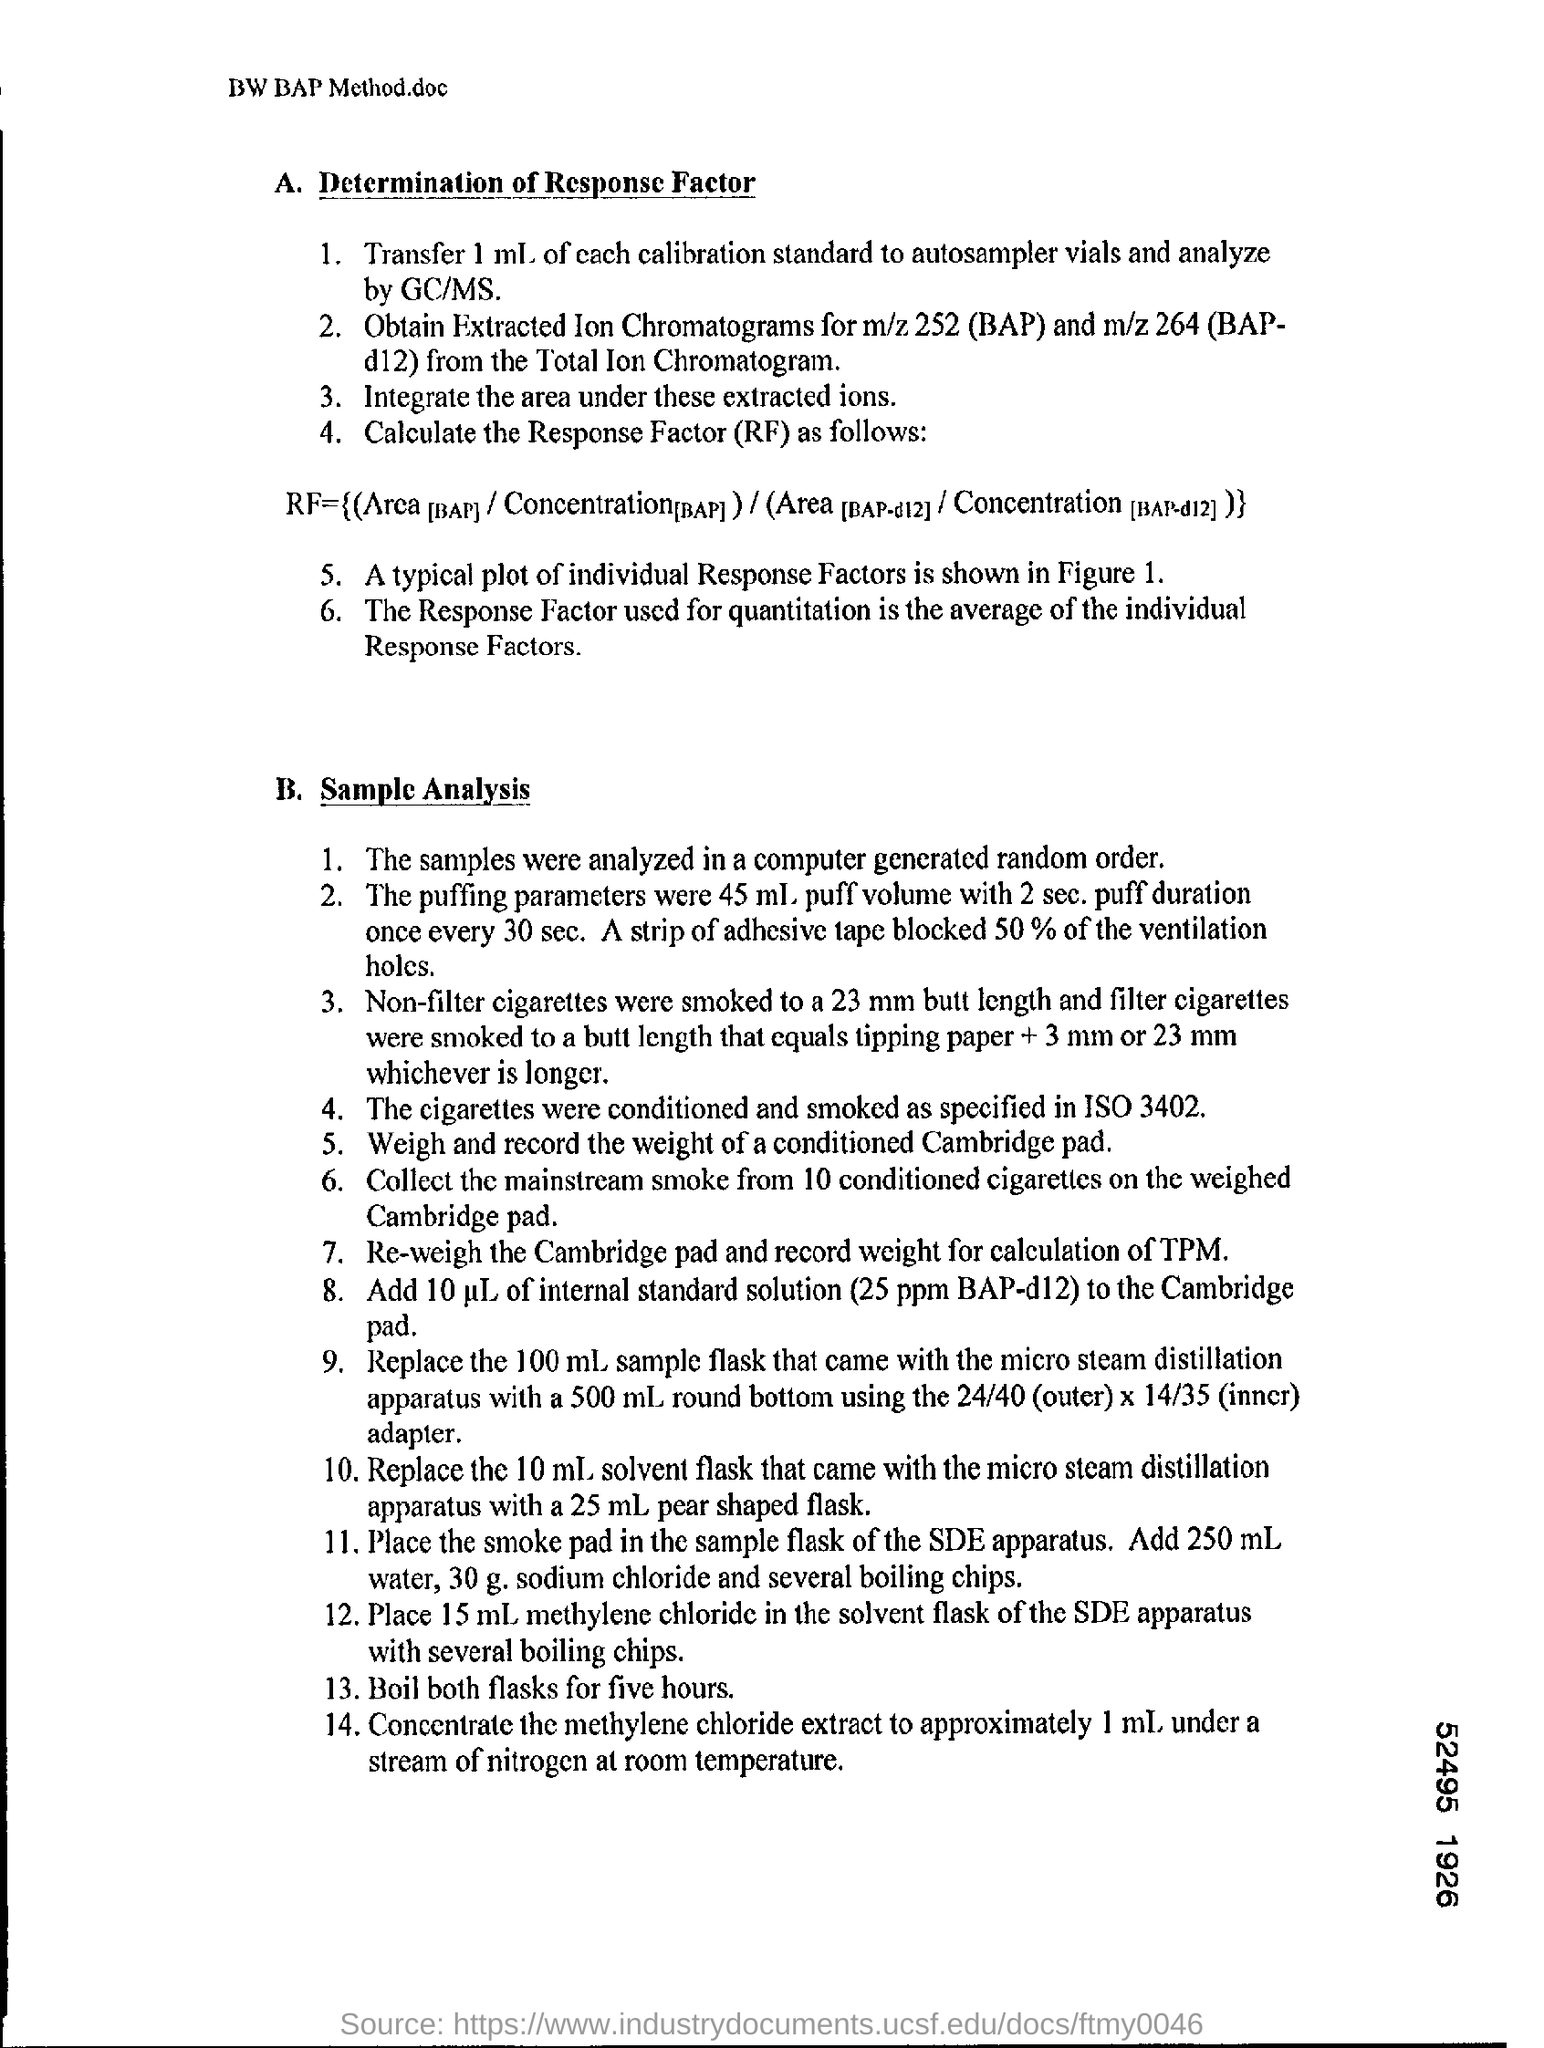Mention a couple of crucial points in this snapshot. The cigarettes were conditioned and smoked according to the specifications outlined in ISO 3402, which is the international standard for cigarette smoke condensation nuclei testing. Applying a strip of adhesive tape to 50% of the ventilation holes significantly impairs the airflow through the system. The response factor used for quantitation is calculated by taking the average of individual response factors. The samples were analyzed in a computer-generated random order. 